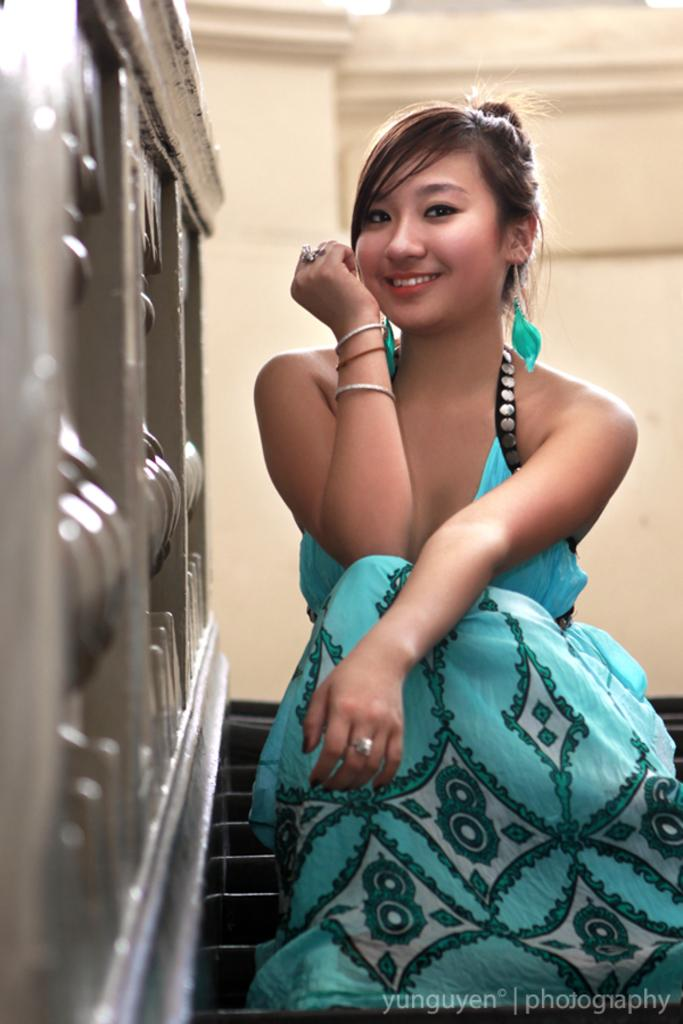Who is the main subject in the foreground of the image? There is a woman in the foreground of the image. What is the woman doing in the image? The woman is on the steps. What can be seen in the foreground besides the woman? There is a text visible in the foreground. What is visible in the background of the image? There is a wall and metal rods in the background of the image. Can you describe the lighting conditions in the image? The image was likely taken during the day, as there is sufficient light to see the details clearly. Where is the rabbit hiding in the hole in the image? There is no rabbit or hole present in the image. 